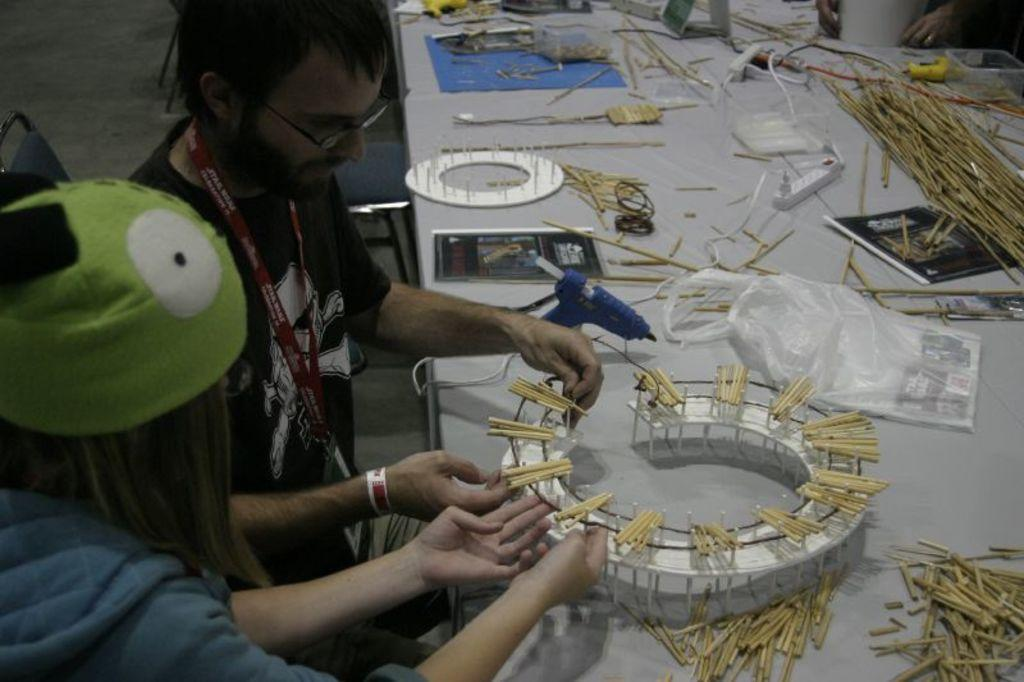How many people are visible in the image? There are two people on the left side of the image. What can be seen on the right side of the image? There are objects on a table on the right side of the image. What type of brass instrument is being played by the people in the image? There is no brass instrument visible in the image; the people are not playing any musical instruments. 